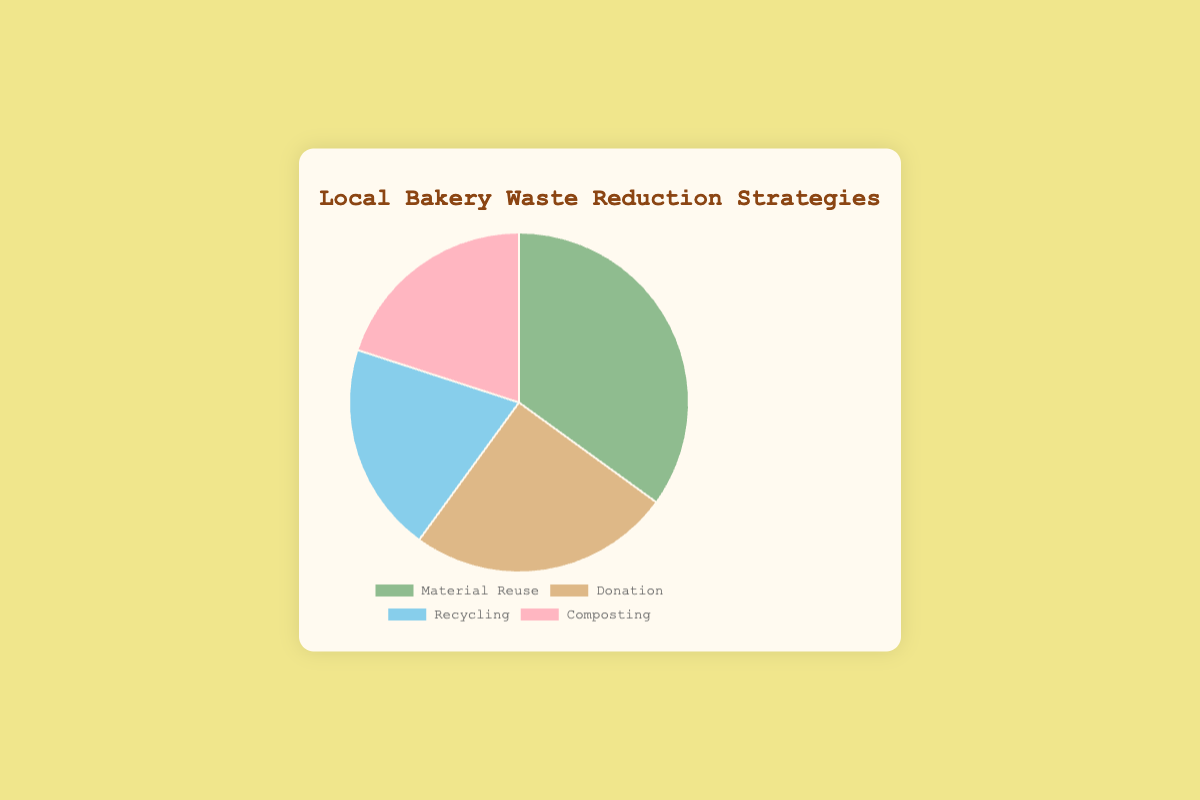What is the most common waste reduction strategy employed by the bakery? The data shows the distribution of percentages among four strategies. The strategy with the highest percentage is the most common. Material Reuse has the highest value of 35%.
Answer: Material Reuse Which two strategies have equal percentages? Examining the percentages for each strategy, Recycling and Composting both have 20%.
Answer: Recycling and Composting What is the total percentage of the strategies other than Material Reuse? The total for strategies other than Material Reuse is calculated by adding the percentages of Donation, Recycling, and Composting: 25% + 20% + 20% = 65%.
Answer: 65% How much higher is the percentage of Material Reuse compared to Donation? Subtract the percentage of Donation from Material Reuse: 35% - 25% = 10%.
Answer: 10% Which strategy is represented by the green slice? Looking at the colors, Material Reuse is green.
Answer: Material Reuse What is the average percentage of all four strategies? Add up all the percentages: 35% + 25% + 20% + 20% = 100%. Divide by 4 to get the average, 100 / 4 = 25%.
Answer: 25% How much greater is the combined percentage of Material Reuse and Donation compared to the combined percentage of Recycling and Composting? First, calculate the sum of Material Reuse and Donation: 35% + 25% = 60%, then sum Recycling and Composting: 20% + 20% = 40%. Subtract the latter from the former: 60% - 40% = 20%.
Answer: 20% If the bakery aims to equally distribute its waste reduction strategy efforts, by what percentage should Material Reuse be reduced to match the average percentage? The average percentage is 25%. Material Reuse is currently at 35%. Reduce Material Reuse by 35% - 25% = 10%.
Answer: 10% 